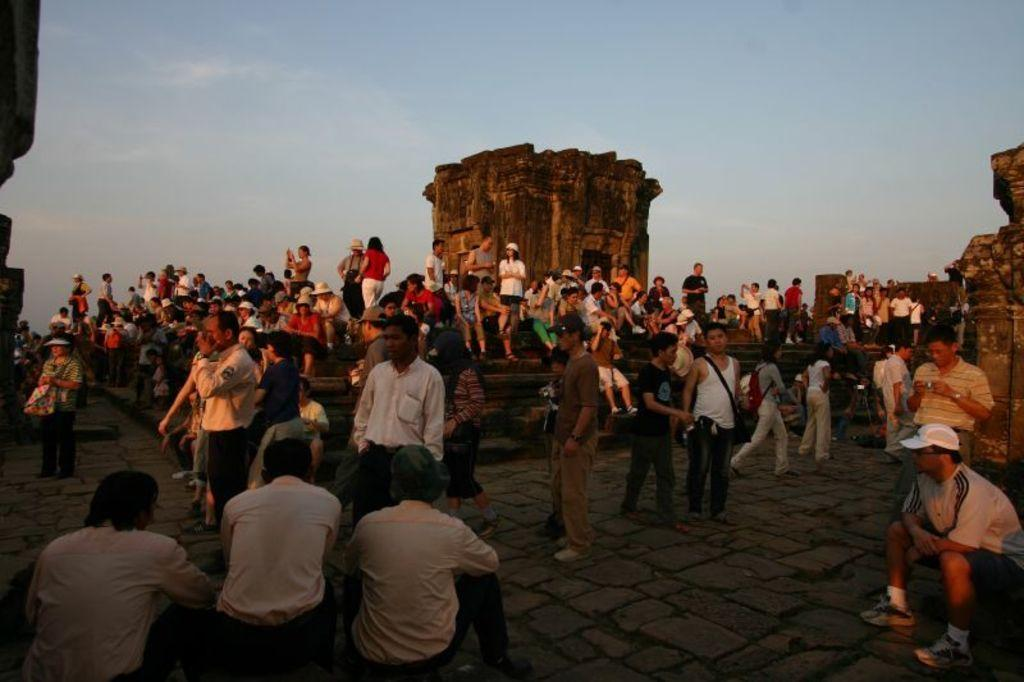What can be seen in the image in terms of people? There are groups of people in the image. What architectural feature is present in the image? There are stairs in the image. What is the background of the image composed of? There is a wall and the sky visible in the image. How would you describe the lighting in the image? The image appears to be slightly dark. What direction is the hose pointing in the image? There is no hose present in the image. Can you identify the friend of the person standing on the stairs? The image does not provide enough information to identify any specific individuals or their relationships. 